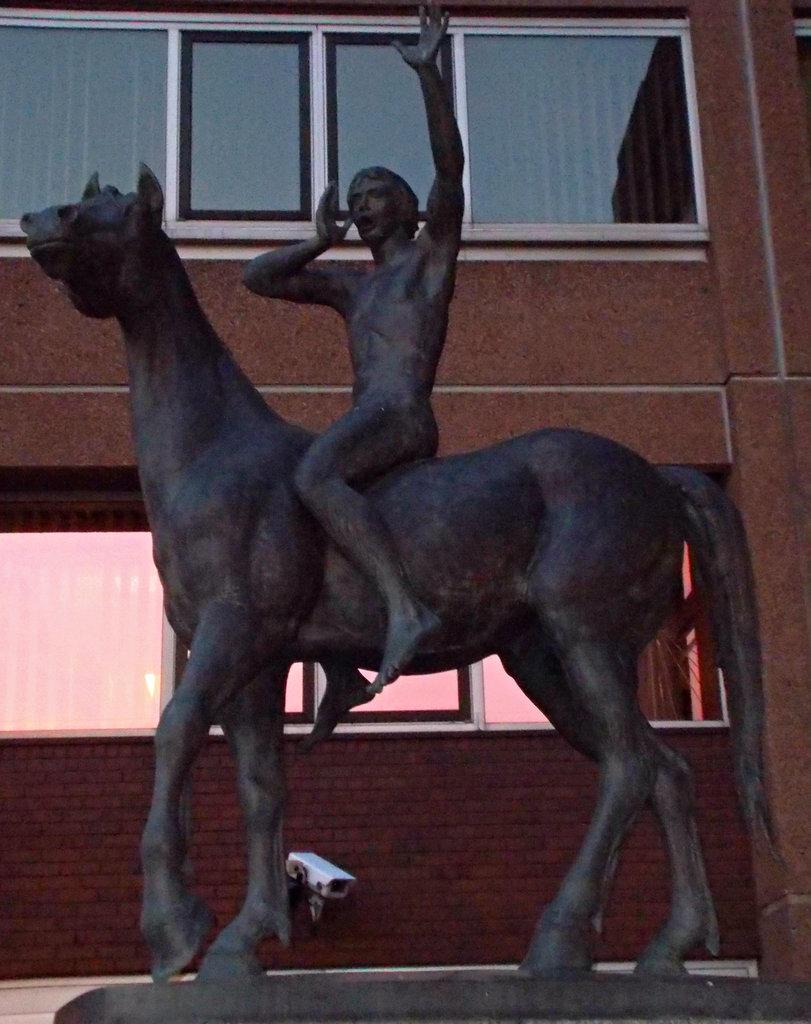What is the main subject of the statue in the image? The main subject of the statue in the image is a man. What is the man doing in the statue? The man is sitting on a horse in the statue. What can be seen in the background of the image? There is a building behind the statue in the image. What type of salt can be seen being harvested in the image? There is no salt or harvesting activity present in the image; it features a statue of a man sitting on a horse with a building in the background. 